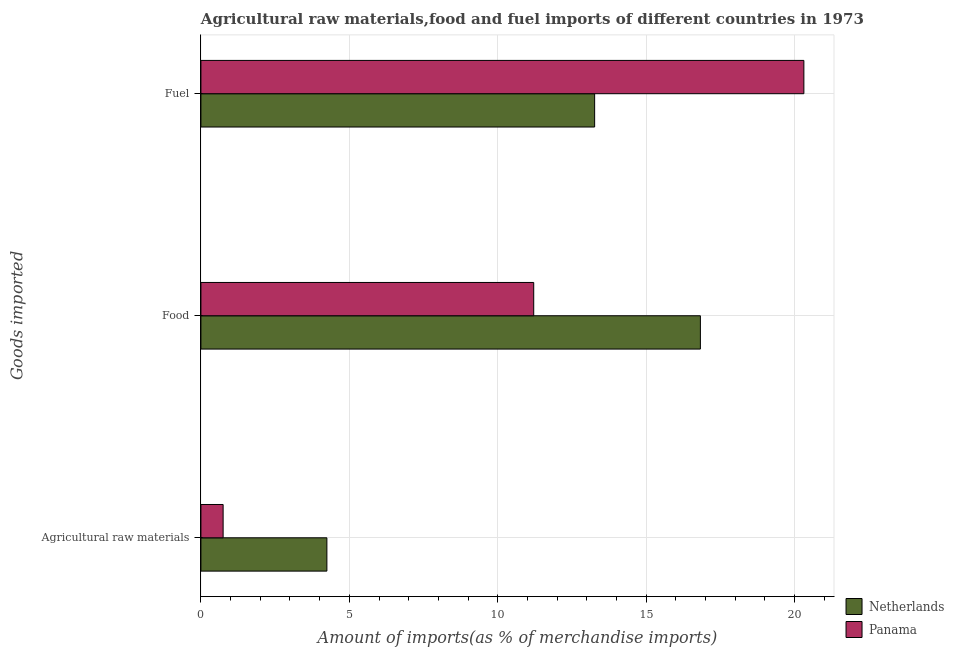How many different coloured bars are there?
Keep it short and to the point. 2. How many bars are there on the 1st tick from the bottom?
Make the answer very short. 2. What is the label of the 3rd group of bars from the top?
Your answer should be compact. Agricultural raw materials. What is the percentage of raw materials imports in Netherlands?
Ensure brevity in your answer.  4.24. Across all countries, what is the maximum percentage of raw materials imports?
Make the answer very short. 4.24. Across all countries, what is the minimum percentage of raw materials imports?
Your response must be concise. 0.75. In which country was the percentage of fuel imports maximum?
Make the answer very short. Panama. What is the total percentage of fuel imports in the graph?
Your answer should be compact. 33.58. What is the difference between the percentage of fuel imports in Netherlands and that in Panama?
Your answer should be compact. -7.05. What is the difference between the percentage of fuel imports in Netherlands and the percentage of raw materials imports in Panama?
Provide a short and direct response. 12.52. What is the average percentage of food imports per country?
Give a very brief answer. 14.02. What is the difference between the percentage of raw materials imports and percentage of fuel imports in Panama?
Provide a short and direct response. -19.57. What is the ratio of the percentage of raw materials imports in Panama to that in Netherlands?
Offer a terse response. 0.18. Is the percentage of food imports in Panama less than that in Netherlands?
Provide a short and direct response. Yes. What is the difference between the highest and the second highest percentage of raw materials imports?
Your answer should be compact. 3.5. What is the difference between the highest and the lowest percentage of fuel imports?
Provide a succinct answer. 7.05. Is the sum of the percentage of fuel imports in Panama and Netherlands greater than the maximum percentage of food imports across all countries?
Provide a succinct answer. Yes. What does the 1st bar from the top in Food represents?
Offer a very short reply. Panama. What does the 1st bar from the bottom in Food represents?
Offer a terse response. Netherlands. Is it the case that in every country, the sum of the percentage of raw materials imports and percentage of food imports is greater than the percentage of fuel imports?
Provide a succinct answer. No. What is the difference between two consecutive major ticks on the X-axis?
Provide a succinct answer. 5. Are the values on the major ticks of X-axis written in scientific E-notation?
Provide a succinct answer. No. Does the graph contain grids?
Your response must be concise. Yes. How are the legend labels stacked?
Ensure brevity in your answer.  Vertical. What is the title of the graph?
Keep it short and to the point. Agricultural raw materials,food and fuel imports of different countries in 1973. What is the label or title of the X-axis?
Offer a very short reply. Amount of imports(as % of merchandise imports). What is the label or title of the Y-axis?
Offer a terse response. Goods imported. What is the Amount of imports(as % of merchandise imports) of Netherlands in Agricultural raw materials?
Give a very brief answer. 4.24. What is the Amount of imports(as % of merchandise imports) in Panama in Agricultural raw materials?
Your response must be concise. 0.75. What is the Amount of imports(as % of merchandise imports) of Netherlands in Food?
Offer a very short reply. 16.83. What is the Amount of imports(as % of merchandise imports) in Panama in Food?
Keep it short and to the point. 11.21. What is the Amount of imports(as % of merchandise imports) in Netherlands in Fuel?
Ensure brevity in your answer.  13.27. What is the Amount of imports(as % of merchandise imports) of Panama in Fuel?
Your response must be concise. 20.31. Across all Goods imported, what is the maximum Amount of imports(as % of merchandise imports) in Netherlands?
Give a very brief answer. 16.83. Across all Goods imported, what is the maximum Amount of imports(as % of merchandise imports) in Panama?
Make the answer very short. 20.31. Across all Goods imported, what is the minimum Amount of imports(as % of merchandise imports) in Netherlands?
Offer a terse response. 4.24. Across all Goods imported, what is the minimum Amount of imports(as % of merchandise imports) in Panama?
Your answer should be very brief. 0.75. What is the total Amount of imports(as % of merchandise imports) in Netherlands in the graph?
Make the answer very short. 34.34. What is the total Amount of imports(as % of merchandise imports) in Panama in the graph?
Your answer should be very brief. 32.28. What is the difference between the Amount of imports(as % of merchandise imports) of Netherlands in Agricultural raw materials and that in Food?
Provide a short and direct response. -12.58. What is the difference between the Amount of imports(as % of merchandise imports) in Panama in Agricultural raw materials and that in Food?
Give a very brief answer. -10.46. What is the difference between the Amount of imports(as % of merchandise imports) in Netherlands in Agricultural raw materials and that in Fuel?
Your response must be concise. -9.02. What is the difference between the Amount of imports(as % of merchandise imports) of Panama in Agricultural raw materials and that in Fuel?
Provide a short and direct response. -19.57. What is the difference between the Amount of imports(as % of merchandise imports) of Netherlands in Food and that in Fuel?
Your response must be concise. 3.56. What is the difference between the Amount of imports(as % of merchandise imports) of Panama in Food and that in Fuel?
Provide a short and direct response. -9.1. What is the difference between the Amount of imports(as % of merchandise imports) of Netherlands in Agricultural raw materials and the Amount of imports(as % of merchandise imports) of Panama in Food?
Provide a succinct answer. -6.97. What is the difference between the Amount of imports(as % of merchandise imports) of Netherlands in Agricultural raw materials and the Amount of imports(as % of merchandise imports) of Panama in Fuel?
Your answer should be compact. -16.07. What is the difference between the Amount of imports(as % of merchandise imports) of Netherlands in Food and the Amount of imports(as % of merchandise imports) of Panama in Fuel?
Give a very brief answer. -3.49. What is the average Amount of imports(as % of merchandise imports) in Netherlands per Goods imported?
Offer a terse response. 11.45. What is the average Amount of imports(as % of merchandise imports) in Panama per Goods imported?
Provide a short and direct response. 10.76. What is the difference between the Amount of imports(as % of merchandise imports) of Netherlands and Amount of imports(as % of merchandise imports) of Panama in Agricultural raw materials?
Provide a succinct answer. 3.5. What is the difference between the Amount of imports(as % of merchandise imports) of Netherlands and Amount of imports(as % of merchandise imports) of Panama in Food?
Offer a very short reply. 5.62. What is the difference between the Amount of imports(as % of merchandise imports) of Netherlands and Amount of imports(as % of merchandise imports) of Panama in Fuel?
Make the answer very short. -7.05. What is the ratio of the Amount of imports(as % of merchandise imports) of Netherlands in Agricultural raw materials to that in Food?
Ensure brevity in your answer.  0.25. What is the ratio of the Amount of imports(as % of merchandise imports) in Panama in Agricultural raw materials to that in Food?
Ensure brevity in your answer.  0.07. What is the ratio of the Amount of imports(as % of merchandise imports) in Netherlands in Agricultural raw materials to that in Fuel?
Offer a very short reply. 0.32. What is the ratio of the Amount of imports(as % of merchandise imports) in Panama in Agricultural raw materials to that in Fuel?
Give a very brief answer. 0.04. What is the ratio of the Amount of imports(as % of merchandise imports) of Netherlands in Food to that in Fuel?
Ensure brevity in your answer.  1.27. What is the ratio of the Amount of imports(as % of merchandise imports) in Panama in Food to that in Fuel?
Ensure brevity in your answer.  0.55. What is the difference between the highest and the second highest Amount of imports(as % of merchandise imports) of Netherlands?
Keep it short and to the point. 3.56. What is the difference between the highest and the second highest Amount of imports(as % of merchandise imports) of Panama?
Make the answer very short. 9.1. What is the difference between the highest and the lowest Amount of imports(as % of merchandise imports) of Netherlands?
Offer a very short reply. 12.58. What is the difference between the highest and the lowest Amount of imports(as % of merchandise imports) in Panama?
Your answer should be compact. 19.57. 